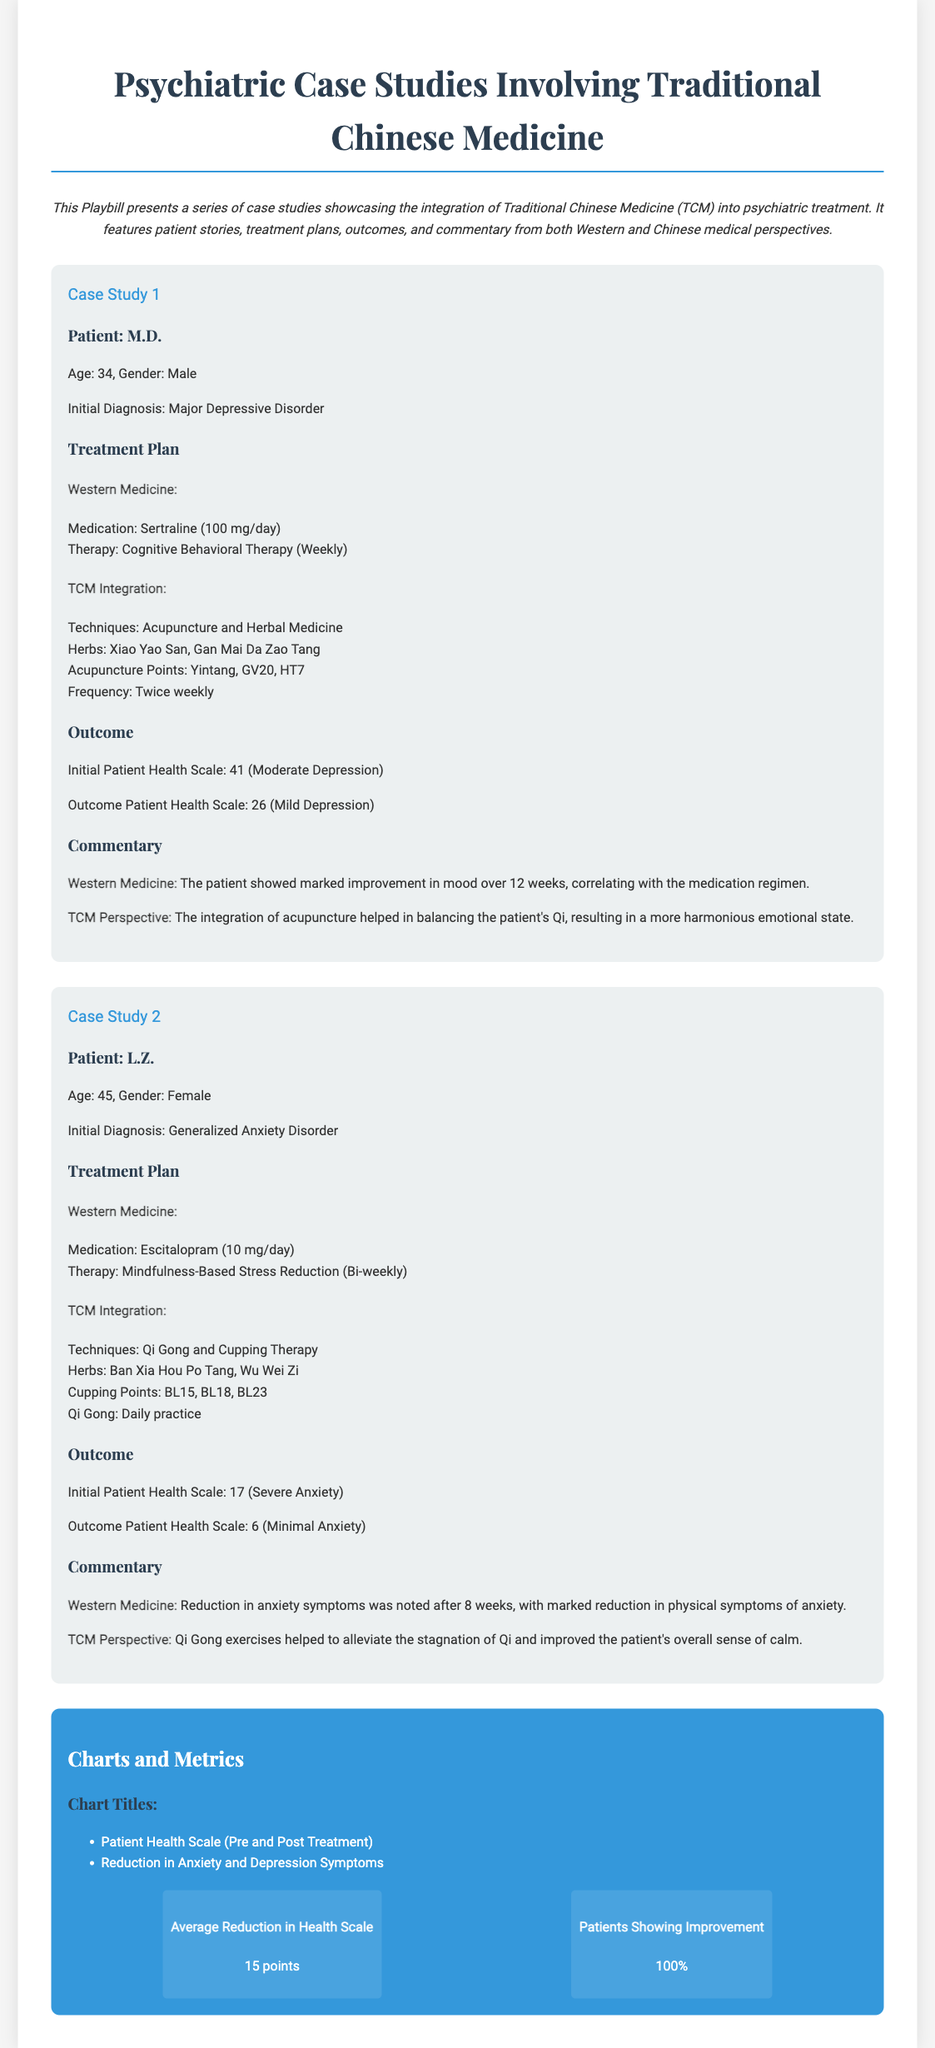What is the age of patient M.D.? The document states the age of patient M.D. as 34.
Answer: 34 What technique was used in patient L.Z.'s treatment plan? According to the document, Qi Gong was one of the techniques used in L.Z.'s treatment plan.
Answer: Qi Gong What was the initial diagnosis of patient L.Z.? The document lists the initial diagnosis of patient L.Z. as Generalized Anxiety Disorder.
Answer: Generalized Anxiety Disorder What is the final Patient Health Scale score for patient M.D.? The outcome section of the document indicates the final Patient Health Scale score for patient M.D. was 26.
Answer: 26 How many points were reduced in the average Health Scale? The document mentions that the average reduction in Health Scale was 15 points.
Answer: 15 points What was the outcome health scale score for patient L.Z.? The outcome section states that the health scale score for patient L.Z. was 6.
Answer: 6 What is the total number of patients showing improvement? The metrics section indicates that 100% of the patients showed improvement.
Answer: 100% What therapy was suggested for patient M.D. in Western Medicine? The document notes that Cognitive Behavioral Therapy was suggested for patient M.D. in Western Medicine.
Answer: Cognitive Behavioral Therapy Which herbs were used in patient M.D.'s TCM integration? The document lists Xiao Yao San and Gan Mai Da Zao Tang as the herbs used in M.D.'s TCM integration.
Answer: Xiao Yao San, Gan Mai Da Zao Tang 